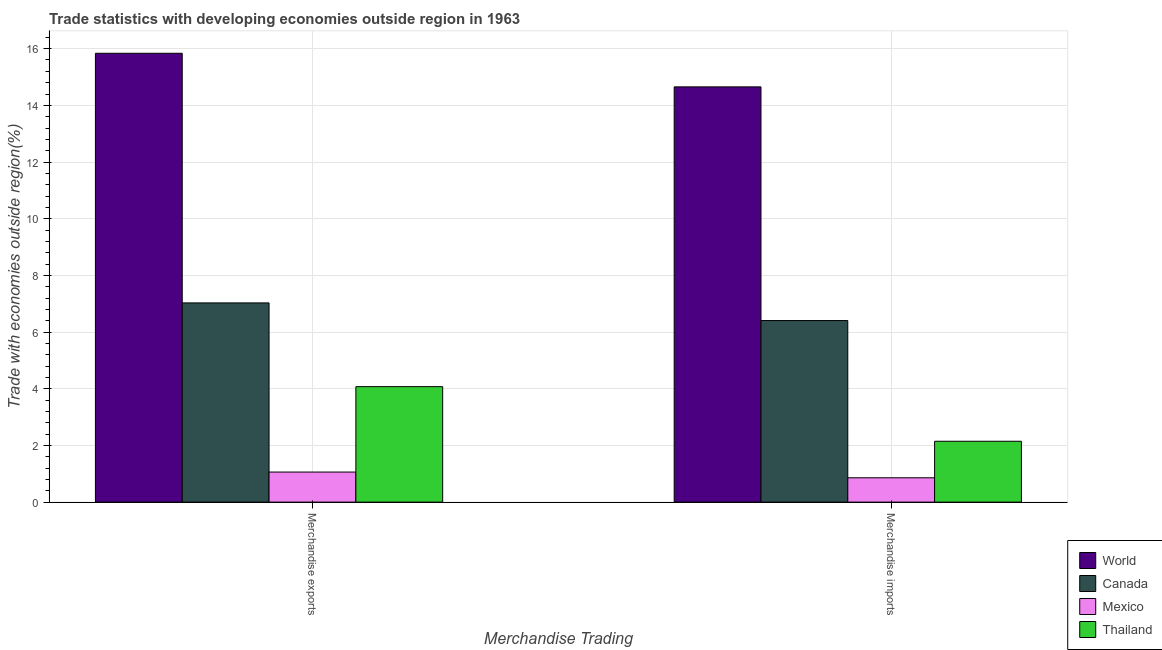How many different coloured bars are there?
Offer a very short reply. 4. Are the number of bars on each tick of the X-axis equal?
Provide a short and direct response. Yes. How many bars are there on the 2nd tick from the right?
Your answer should be very brief. 4. What is the merchandise exports in Thailand?
Offer a terse response. 4.07. Across all countries, what is the maximum merchandise exports?
Make the answer very short. 15.84. Across all countries, what is the minimum merchandise imports?
Your answer should be compact. 0.86. In which country was the merchandise imports minimum?
Your answer should be compact. Mexico. What is the total merchandise imports in the graph?
Keep it short and to the point. 24.06. What is the difference between the merchandise exports in World and that in Canada?
Offer a terse response. 8.81. What is the difference between the merchandise imports in World and the merchandise exports in Canada?
Your answer should be very brief. 7.62. What is the average merchandise exports per country?
Offer a very short reply. 7. What is the difference between the merchandise imports and merchandise exports in Canada?
Offer a terse response. -0.62. What is the ratio of the merchandise exports in Thailand to that in Canada?
Your answer should be compact. 0.58. In how many countries, is the merchandise imports greater than the average merchandise imports taken over all countries?
Offer a terse response. 2. How many bars are there?
Offer a terse response. 8. How many countries are there in the graph?
Offer a very short reply. 4. What is the difference between two consecutive major ticks on the Y-axis?
Provide a succinct answer. 2. Are the values on the major ticks of Y-axis written in scientific E-notation?
Your answer should be compact. No. Does the graph contain any zero values?
Your answer should be very brief. No. Does the graph contain grids?
Your response must be concise. Yes. Where does the legend appear in the graph?
Ensure brevity in your answer.  Bottom right. How are the legend labels stacked?
Provide a succinct answer. Vertical. What is the title of the graph?
Offer a very short reply. Trade statistics with developing economies outside region in 1963. What is the label or title of the X-axis?
Give a very brief answer. Merchandise Trading. What is the label or title of the Y-axis?
Keep it short and to the point. Trade with economies outside region(%). What is the Trade with economies outside region(%) in World in Merchandise exports?
Offer a terse response. 15.84. What is the Trade with economies outside region(%) of Canada in Merchandise exports?
Your answer should be compact. 7.03. What is the Trade with economies outside region(%) in Mexico in Merchandise exports?
Give a very brief answer. 1.06. What is the Trade with economies outside region(%) of Thailand in Merchandise exports?
Give a very brief answer. 4.07. What is the Trade with economies outside region(%) of World in Merchandise imports?
Keep it short and to the point. 14.65. What is the Trade with economies outside region(%) in Canada in Merchandise imports?
Your answer should be very brief. 6.41. What is the Trade with economies outside region(%) of Mexico in Merchandise imports?
Provide a short and direct response. 0.86. What is the Trade with economies outside region(%) of Thailand in Merchandise imports?
Provide a succinct answer. 2.15. Across all Merchandise Trading, what is the maximum Trade with economies outside region(%) in World?
Provide a short and direct response. 15.84. Across all Merchandise Trading, what is the maximum Trade with economies outside region(%) of Canada?
Make the answer very short. 7.03. Across all Merchandise Trading, what is the maximum Trade with economies outside region(%) of Mexico?
Your response must be concise. 1.06. Across all Merchandise Trading, what is the maximum Trade with economies outside region(%) of Thailand?
Your response must be concise. 4.07. Across all Merchandise Trading, what is the minimum Trade with economies outside region(%) in World?
Your answer should be compact. 14.65. Across all Merchandise Trading, what is the minimum Trade with economies outside region(%) in Canada?
Your answer should be very brief. 6.41. Across all Merchandise Trading, what is the minimum Trade with economies outside region(%) in Mexico?
Keep it short and to the point. 0.86. Across all Merchandise Trading, what is the minimum Trade with economies outside region(%) of Thailand?
Your answer should be very brief. 2.15. What is the total Trade with economies outside region(%) in World in the graph?
Keep it short and to the point. 30.49. What is the total Trade with economies outside region(%) in Canada in the graph?
Your answer should be very brief. 13.44. What is the total Trade with economies outside region(%) in Mexico in the graph?
Your answer should be very brief. 1.92. What is the total Trade with economies outside region(%) of Thailand in the graph?
Offer a terse response. 6.22. What is the difference between the Trade with economies outside region(%) in World in Merchandise exports and that in Merchandise imports?
Keep it short and to the point. 1.19. What is the difference between the Trade with economies outside region(%) in Canada in Merchandise exports and that in Merchandise imports?
Provide a short and direct response. 0.62. What is the difference between the Trade with economies outside region(%) in Mexico in Merchandise exports and that in Merchandise imports?
Give a very brief answer. 0.2. What is the difference between the Trade with economies outside region(%) in Thailand in Merchandise exports and that in Merchandise imports?
Give a very brief answer. 1.93. What is the difference between the Trade with economies outside region(%) of World in Merchandise exports and the Trade with economies outside region(%) of Canada in Merchandise imports?
Make the answer very short. 9.43. What is the difference between the Trade with economies outside region(%) of World in Merchandise exports and the Trade with economies outside region(%) of Mexico in Merchandise imports?
Keep it short and to the point. 14.98. What is the difference between the Trade with economies outside region(%) of World in Merchandise exports and the Trade with economies outside region(%) of Thailand in Merchandise imports?
Provide a succinct answer. 13.69. What is the difference between the Trade with economies outside region(%) of Canada in Merchandise exports and the Trade with economies outside region(%) of Mexico in Merchandise imports?
Your answer should be compact. 6.17. What is the difference between the Trade with economies outside region(%) of Canada in Merchandise exports and the Trade with economies outside region(%) of Thailand in Merchandise imports?
Provide a succinct answer. 4.88. What is the difference between the Trade with economies outside region(%) of Mexico in Merchandise exports and the Trade with economies outside region(%) of Thailand in Merchandise imports?
Keep it short and to the point. -1.09. What is the average Trade with economies outside region(%) in World per Merchandise Trading?
Make the answer very short. 15.24. What is the average Trade with economies outside region(%) in Canada per Merchandise Trading?
Keep it short and to the point. 6.72. What is the average Trade with economies outside region(%) of Mexico per Merchandise Trading?
Your answer should be very brief. 0.96. What is the average Trade with economies outside region(%) of Thailand per Merchandise Trading?
Your response must be concise. 3.11. What is the difference between the Trade with economies outside region(%) in World and Trade with economies outside region(%) in Canada in Merchandise exports?
Provide a short and direct response. 8.81. What is the difference between the Trade with economies outside region(%) in World and Trade with economies outside region(%) in Mexico in Merchandise exports?
Make the answer very short. 14.78. What is the difference between the Trade with economies outside region(%) of World and Trade with economies outside region(%) of Thailand in Merchandise exports?
Give a very brief answer. 11.76. What is the difference between the Trade with economies outside region(%) in Canada and Trade with economies outside region(%) in Mexico in Merchandise exports?
Give a very brief answer. 5.97. What is the difference between the Trade with economies outside region(%) in Canada and Trade with economies outside region(%) in Thailand in Merchandise exports?
Provide a succinct answer. 2.95. What is the difference between the Trade with economies outside region(%) in Mexico and Trade with economies outside region(%) in Thailand in Merchandise exports?
Your answer should be very brief. -3.01. What is the difference between the Trade with economies outside region(%) of World and Trade with economies outside region(%) of Canada in Merchandise imports?
Keep it short and to the point. 8.25. What is the difference between the Trade with economies outside region(%) in World and Trade with economies outside region(%) in Mexico in Merchandise imports?
Offer a very short reply. 13.79. What is the difference between the Trade with economies outside region(%) of World and Trade with economies outside region(%) of Thailand in Merchandise imports?
Offer a very short reply. 12.5. What is the difference between the Trade with economies outside region(%) of Canada and Trade with economies outside region(%) of Mexico in Merchandise imports?
Keep it short and to the point. 5.55. What is the difference between the Trade with economies outside region(%) in Canada and Trade with economies outside region(%) in Thailand in Merchandise imports?
Provide a short and direct response. 4.26. What is the difference between the Trade with economies outside region(%) in Mexico and Trade with economies outside region(%) in Thailand in Merchandise imports?
Give a very brief answer. -1.29. What is the ratio of the Trade with economies outside region(%) of World in Merchandise exports to that in Merchandise imports?
Your answer should be compact. 1.08. What is the ratio of the Trade with economies outside region(%) of Canada in Merchandise exports to that in Merchandise imports?
Make the answer very short. 1.1. What is the ratio of the Trade with economies outside region(%) in Mexico in Merchandise exports to that in Merchandise imports?
Provide a succinct answer. 1.24. What is the ratio of the Trade with economies outside region(%) in Thailand in Merchandise exports to that in Merchandise imports?
Make the answer very short. 1.9. What is the difference between the highest and the second highest Trade with economies outside region(%) of World?
Your response must be concise. 1.19. What is the difference between the highest and the second highest Trade with economies outside region(%) in Canada?
Your response must be concise. 0.62. What is the difference between the highest and the second highest Trade with economies outside region(%) of Mexico?
Give a very brief answer. 0.2. What is the difference between the highest and the second highest Trade with economies outside region(%) of Thailand?
Give a very brief answer. 1.93. What is the difference between the highest and the lowest Trade with economies outside region(%) in World?
Provide a succinct answer. 1.19. What is the difference between the highest and the lowest Trade with economies outside region(%) of Canada?
Provide a short and direct response. 0.62. What is the difference between the highest and the lowest Trade with economies outside region(%) of Mexico?
Offer a terse response. 0.2. What is the difference between the highest and the lowest Trade with economies outside region(%) of Thailand?
Offer a very short reply. 1.93. 